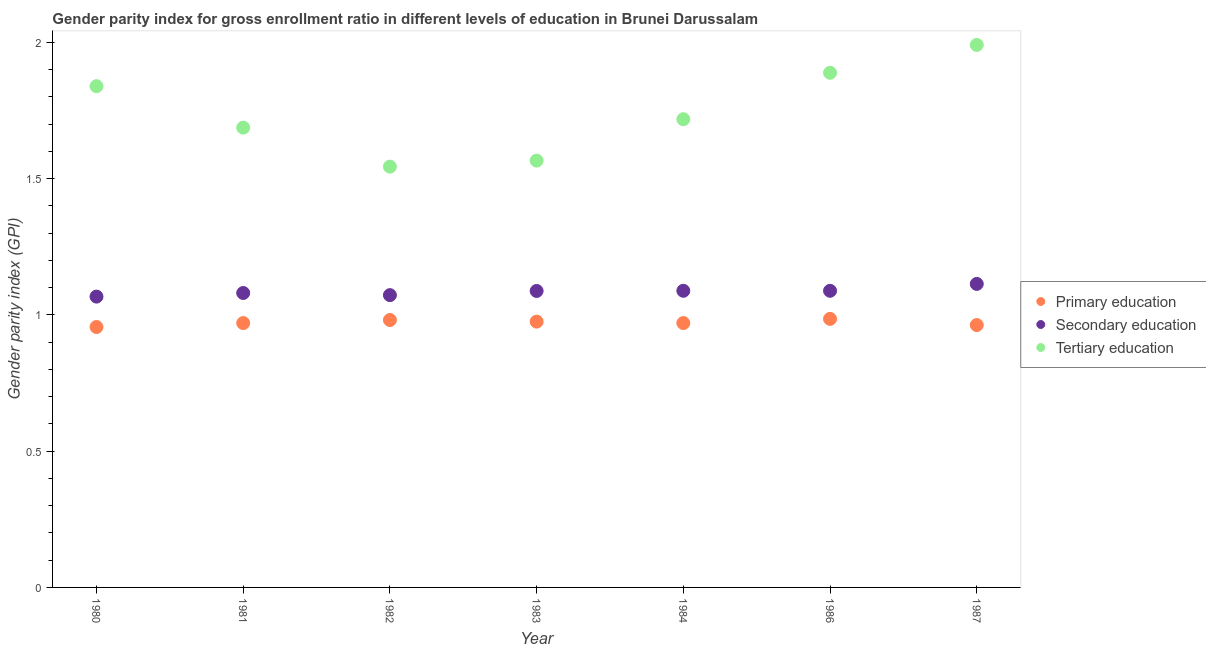What is the gender parity index in tertiary education in 1981?
Ensure brevity in your answer.  1.69. Across all years, what is the maximum gender parity index in secondary education?
Give a very brief answer. 1.11. Across all years, what is the minimum gender parity index in tertiary education?
Keep it short and to the point. 1.54. In which year was the gender parity index in tertiary education maximum?
Ensure brevity in your answer.  1987. In which year was the gender parity index in primary education minimum?
Ensure brevity in your answer.  1980. What is the total gender parity index in primary education in the graph?
Provide a short and direct response. 6.8. What is the difference between the gender parity index in primary education in 1984 and that in 1986?
Make the answer very short. -0.02. What is the difference between the gender parity index in tertiary education in 1981 and the gender parity index in secondary education in 1987?
Make the answer very short. 0.57. What is the average gender parity index in secondary education per year?
Ensure brevity in your answer.  1.09. In the year 1981, what is the difference between the gender parity index in primary education and gender parity index in tertiary education?
Make the answer very short. -0.72. What is the ratio of the gender parity index in primary education in 1986 to that in 1987?
Your answer should be compact. 1.02. Is the gender parity index in primary education in 1980 less than that in 1983?
Offer a very short reply. Yes. Is the difference between the gender parity index in secondary education in 1983 and 1986 greater than the difference between the gender parity index in primary education in 1983 and 1986?
Offer a very short reply. Yes. What is the difference between the highest and the second highest gender parity index in tertiary education?
Provide a short and direct response. 0.1. What is the difference between the highest and the lowest gender parity index in secondary education?
Offer a terse response. 0.05. Does the gender parity index in tertiary education monotonically increase over the years?
Offer a very short reply. No. Is the gender parity index in secondary education strictly greater than the gender parity index in primary education over the years?
Provide a short and direct response. Yes. Are the values on the major ticks of Y-axis written in scientific E-notation?
Your response must be concise. No. What is the title of the graph?
Your response must be concise. Gender parity index for gross enrollment ratio in different levels of education in Brunei Darussalam. What is the label or title of the Y-axis?
Provide a short and direct response. Gender parity index (GPI). What is the Gender parity index (GPI) in Primary education in 1980?
Ensure brevity in your answer.  0.96. What is the Gender parity index (GPI) of Secondary education in 1980?
Your response must be concise. 1.07. What is the Gender parity index (GPI) of Tertiary education in 1980?
Ensure brevity in your answer.  1.84. What is the Gender parity index (GPI) of Primary education in 1981?
Offer a very short reply. 0.97. What is the Gender parity index (GPI) of Secondary education in 1981?
Your answer should be very brief. 1.08. What is the Gender parity index (GPI) of Tertiary education in 1981?
Ensure brevity in your answer.  1.69. What is the Gender parity index (GPI) in Primary education in 1982?
Offer a terse response. 0.98. What is the Gender parity index (GPI) in Secondary education in 1982?
Give a very brief answer. 1.07. What is the Gender parity index (GPI) in Tertiary education in 1982?
Make the answer very short. 1.54. What is the Gender parity index (GPI) in Primary education in 1983?
Provide a short and direct response. 0.98. What is the Gender parity index (GPI) in Secondary education in 1983?
Provide a short and direct response. 1.09. What is the Gender parity index (GPI) of Tertiary education in 1983?
Offer a terse response. 1.57. What is the Gender parity index (GPI) of Primary education in 1984?
Provide a short and direct response. 0.97. What is the Gender parity index (GPI) in Secondary education in 1984?
Offer a terse response. 1.09. What is the Gender parity index (GPI) in Tertiary education in 1984?
Your response must be concise. 1.72. What is the Gender parity index (GPI) in Primary education in 1986?
Offer a terse response. 0.99. What is the Gender parity index (GPI) of Secondary education in 1986?
Keep it short and to the point. 1.09. What is the Gender parity index (GPI) of Tertiary education in 1986?
Ensure brevity in your answer.  1.89. What is the Gender parity index (GPI) of Primary education in 1987?
Make the answer very short. 0.96. What is the Gender parity index (GPI) in Secondary education in 1987?
Your answer should be compact. 1.11. What is the Gender parity index (GPI) of Tertiary education in 1987?
Your response must be concise. 1.99. Across all years, what is the maximum Gender parity index (GPI) in Primary education?
Offer a terse response. 0.99. Across all years, what is the maximum Gender parity index (GPI) of Secondary education?
Your response must be concise. 1.11. Across all years, what is the maximum Gender parity index (GPI) of Tertiary education?
Your answer should be compact. 1.99. Across all years, what is the minimum Gender parity index (GPI) in Primary education?
Make the answer very short. 0.96. Across all years, what is the minimum Gender parity index (GPI) in Secondary education?
Your answer should be very brief. 1.07. Across all years, what is the minimum Gender parity index (GPI) in Tertiary education?
Make the answer very short. 1.54. What is the total Gender parity index (GPI) in Primary education in the graph?
Your answer should be very brief. 6.8. What is the total Gender parity index (GPI) in Secondary education in the graph?
Your answer should be compact. 7.6. What is the total Gender parity index (GPI) of Tertiary education in the graph?
Make the answer very short. 12.23. What is the difference between the Gender parity index (GPI) of Primary education in 1980 and that in 1981?
Offer a terse response. -0.01. What is the difference between the Gender parity index (GPI) of Secondary education in 1980 and that in 1981?
Make the answer very short. -0.01. What is the difference between the Gender parity index (GPI) of Tertiary education in 1980 and that in 1981?
Provide a short and direct response. 0.15. What is the difference between the Gender parity index (GPI) in Primary education in 1980 and that in 1982?
Provide a short and direct response. -0.03. What is the difference between the Gender parity index (GPI) in Secondary education in 1980 and that in 1982?
Your answer should be compact. -0.01. What is the difference between the Gender parity index (GPI) of Tertiary education in 1980 and that in 1982?
Offer a terse response. 0.3. What is the difference between the Gender parity index (GPI) in Primary education in 1980 and that in 1983?
Provide a succinct answer. -0.02. What is the difference between the Gender parity index (GPI) in Secondary education in 1980 and that in 1983?
Your answer should be compact. -0.02. What is the difference between the Gender parity index (GPI) in Tertiary education in 1980 and that in 1983?
Provide a succinct answer. 0.27. What is the difference between the Gender parity index (GPI) of Primary education in 1980 and that in 1984?
Provide a short and direct response. -0.01. What is the difference between the Gender parity index (GPI) of Secondary education in 1980 and that in 1984?
Your answer should be compact. -0.02. What is the difference between the Gender parity index (GPI) of Tertiary education in 1980 and that in 1984?
Your answer should be very brief. 0.12. What is the difference between the Gender parity index (GPI) in Primary education in 1980 and that in 1986?
Give a very brief answer. -0.03. What is the difference between the Gender parity index (GPI) of Secondary education in 1980 and that in 1986?
Your answer should be very brief. -0.02. What is the difference between the Gender parity index (GPI) in Tertiary education in 1980 and that in 1986?
Keep it short and to the point. -0.05. What is the difference between the Gender parity index (GPI) in Primary education in 1980 and that in 1987?
Provide a succinct answer. -0.01. What is the difference between the Gender parity index (GPI) in Secondary education in 1980 and that in 1987?
Make the answer very short. -0.05. What is the difference between the Gender parity index (GPI) of Tertiary education in 1980 and that in 1987?
Keep it short and to the point. -0.15. What is the difference between the Gender parity index (GPI) in Primary education in 1981 and that in 1982?
Give a very brief answer. -0.01. What is the difference between the Gender parity index (GPI) of Secondary education in 1981 and that in 1982?
Your response must be concise. 0.01. What is the difference between the Gender parity index (GPI) in Tertiary education in 1981 and that in 1982?
Ensure brevity in your answer.  0.14. What is the difference between the Gender parity index (GPI) in Primary education in 1981 and that in 1983?
Provide a short and direct response. -0.01. What is the difference between the Gender parity index (GPI) in Secondary education in 1981 and that in 1983?
Your answer should be very brief. -0.01. What is the difference between the Gender parity index (GPI) of Tertiary education in 1981 and that in 1983?
Ensure brevity in your answer.  0.12. What is the difference between the Gender parity index (GPI) in Primary education in 1981 and that in 1984?
Provide a short and direct response. -0. What is the difference between the Gender parity index (GPI) in Secondary education in 1981 and that in 1984?
Your response must be concise. -0.01. What is the difference between the Gender parity index (GPI) of Tertiary education in 1981 and that in 1984?
Offer a very short reply. -0.03. What is the difference between the Gender parity index (GPI) of Primary education in 1981 and that in 1986?
Your answer should be very brief. -0.02. What is the difference between the Gender parity index (GPI) of Secondary education in 1981 and that in 1986?
Provide a succinct answer. -0.01. What is the difference between the Gender parity index (GPI) of Tertiary education in 1981 and that in 1986?
Offer a terse response. -0.2. What is the difference between the Gender parity index (GPI) of Primary education in 1981 and that in 1987?
Give a very brief answer. 0.01. What is the difference between the Gender parity index (GPI) of Secondary education in 1981 and that in 1987?
Make the answer very short. -0.03. What is the difference between the Gender parity index (GPI) in Tertiary education in 1981 and that in 1987?
Offer a terse response. -0.3. What is the difference between the Gender parity index (GPI) of Primary education in 1982 and that in 1983?
Keep it short and to the point. 0.01. What is the difference between the Gender parity index (GPI) in Secondary education in 1982 and that in 1983?
Give a very brief answer. -0.02. What is the difference between the Gender parity index (GPI) of Tertiary education in 1982 and that in 1983?
Provide a short and direct response. -0.02. What is the difference between the Gender parity index (GPI) of Primary education in 1982 and that in 1984?
Provide a succinct answer. 0.01. What is the difference between the Gender parity index (GPI) of Secondary education in 1982 and that in 1984?
Offer a terse response. -0.02. What is the difference between the Gender parity index (GPI) in Tertiary education in 1982 and that in 1984?
Your response must be concise. -0.17. What is the difference between the Gender parity index (GPI) of Primary education in 1982 and that in 1986?
Your answer should be compact. -0. What is the difference between the Gender parity index (GPI) in Secondary education in 1982 and that in 1986?
Your answer should be very brief. -0.02. What is the difference between the Gender parity index (GPI) in Tertiary education in 1982 and that in 1986?
Make the answer very short. -0.34. What is the difference between the Gender parity index (GPI) in Primary education in 1982 and that in 1987?
Provide a short and direct response. 0.02. What is the difference between the Gender parity index (GPI) of Secondary education in 1982 and that in 1987?
Make the answer very short. -0.04. What is the difference between the Gender parity index (GPI) of Tertiary education in 1982 and that in 1987?
Keep it short and to the point. -0.45. What is the difference between the Gender parity index (GPI) in Primary education in 1983 and that in 1984?
Ensure brevity in your answer.  0.01. What is the difference between the Gender parity index (GPI) in Secondary education in 1983 and that in 1984?
Your response must be concise. -0. What is the difference between the Gender parity index (GPI) in Tertiary education in 1983 and that in 1984?
Keep it short and to the point. -0.15. What is the difference between the Gender parity index (GPI) of Primary education in 1983 and that in 1986?
Give a very brief answer. -0.01. What is the difference between the Gender parity index (GPI) in Secondary education in 1983 and that in 1986?
Make the answer very short. -0. What is the difference between the Gender parity index (GPI) of Tertiary education in 1983 and that in 1986?
Your answer should be compact. -0.32. What is the difference between the Gender parity index (GPI) in Primary education in 1983 and that in 1987?
Offer a terse response. 0.01. What is the difference between the Gender parity index (GPI) of Secondary education in 1983 and that in 1987?
Your response must be concise. -0.03. What is the difference between the Gender parity index (GPI) in Tertiary education in 1983 and that in 1987?
Provide a succinct answer. -0.42. What is the difference between the Gender parity index (GPI) of Primary education in 1984 and that in 1986?
Your answer should be very brief. -0.02. What is the difference between the Gender parity index (GPI) in Secondary education in 1984 and that in 1986?
Keep it short and to the point. 0. What is the difference between the Gender parity index (GPI) in Tertiary education in 1984 and that in 1986?
Your response must be concise. -0.17. What is the difference between the Gender parity index (GPI) of Primary education in 1984 and that in 1987?
Offer a very short reply. 0.01. What is the difference between the Gender parity index (GPI) in Secondary education in 1984 and that in 1987?
Make the answer very short. -0.03. What is the difference between the Gender parity index (GPI) of Tertiary education in 1984 and that in 1987?
Provide a succinct answer. -0.27. What is the difference between the Gender parity index (GPI) of Primary education in 1986 and that in 1987?
Offer a terse response. 0.02. What is the difference between the Gender parity index (GPI) in Secondary education in 1986 and that in 1987?
Offer a terse response. -0.03. What is the difference between the Gender parity index (GPI) in Tertiary education in 1986 and that in 1987?
Give a very brief answer. -0.1. What is the difference between the Gender parity index (GPI) of Primary education in 1980 and the Gender parity index (GPI) of Secondary education in 1981?
Your answer should be compact. -0.12. What is the difference between the Gender parity index (GPI) of Primary education in 1980 and the Gender parity index (GPI) of Tertiary education in 1981?
Your answer should be very brief. -0.73. What is the difference between the Gender parity index (GPI) in Secondary education in 1980 and the Gender parity index (GPI) in Tertiary education in 1981?
Provide a succinct answer. -0.62. What is the difference between the Gender parity index (GPI) of Primary education in 1980 and the Gender parity index (GPI) of Secondary education in 1982?
Ensure brevity in your answer.  -0.12. What is the difference between the Gender parity index (GPI) in Primary education in 1980 and the Gender parity index (GPI) in Tertiary education in 1982?
Your answer should be very brief. -0.59. What is the difference between the Gender parity index (GPI) in Secondary education in 1980 and the Gender parity index (GPI) in Tertiary education in 1982?
Provide a short and direct response. -0.48. What is the difference between the Gender parity index (GPI) in Primary education in 1980 and the Gender parity index (GPI) in Secondary education in 1983?
Provide a succinct answer. -0.13. What is the difference between the Gender parity index (GPI) of Primary education in 1980 and the Gender parity index (GPI) of Tertiary education in 1983?
Provide a short and direct response. -0.61. What is the difference between the Gender parity index (GPI) of Secondary education in 1980 and the Gender parity index (GPI) of Tertiary education in 1983?
Ensure brevity in your answer.  -0.5. What is the difference between the Gender parity index (GPI) in Primary education in 1980 and the Gender parity index (GPI) in Secondary education in 1984?
Your answer should be very brief. -0.13. What is the difference between the Gender parity index (GPI) of Primary education in 1980 and the Gender parity index (GPI) of Tertiary education in 1984?
Your response must be concise. -0.76. What is the difference between the Gender parity index (GPI) of Secondary education in 1980 and the Gender parity index (GPI) of Tertiary education in 1984?
Give a very brief answer. -0.65. What is the difference between the Gender parity index (GPI) in Primary education in 1980 and the Gender parity index (GPI) in Secondary education in 1986?
Ensure brevity in your answer.  -0.13. What is the difference between the Gender parity index (GPI) of Primary education in 1980 and the Gender parity index (GPI) of Tertiary education in 1986?
Keep it short and to the point. -0.93. What is the difference between the Gender parity index (GPI) in Secondary education in 1980 and the Gender parity index (GPI) in Tertiary education in 1986?
Give a very brief answer. -0.82. What is the difference between the Gender parity index (GPI) of Primary education in 1980 and the Gender parity index (GPI) of Secondary education in 1987?
Offer a terse response. -0.16. What is the difference between the Gender parity index (GPI) in Primary education in 1980 and the Gender parity index (GPI) in Tertiary education in 1987?
Offer a terse response. -1.03. What is the difference between the Gender parity index (GPI) of Secondary education in 1980 and the Gender parity index (GPI) of Tertiary education in 1987?
Keep it short and to the point. -0.92. What is the difference between the Gender parity index (GPI) of Primary education in 1981 and the Gender parity index (GPI) of Secondary education in 1982?
Your response must be concise. -0.1. What is the difference between the Gender parity index (GPI) of Primary education in 1981 and the Gender parity index (GPI) of Tertiary education in 1982?
Offer a terse response. -0.57. What is the difference between the Gender parity index (GPI) in Secondary education in 1981 and the Gender parity index (GPI) in Tertiary education in 1982?
Make the answer very short. -0.46. What is the difference between the Gender parity index (GPI) in Primary education in 1981 and the Gender parity index (GPI) in Secondary education in 1983?
Offer a terse response. -0.12. What is the difference between the Gender parity index (GPI) in Primary education in 1981 and the Gender parity index (GPI) in Tertiary education in 1983?
Your response must be concise. -0.6. What is the difference between the Gender parity index (GPI) of Secondary education in 1981 and the Gender parity index (GPI) of Tertiary education in 1983?
Your response must be concise. -0.49. What is the difference between the Gender parity index (GPI) in Primary education in 1981 and the Gender parity index (GPI) in Secondary education in 1984?
Offer a terse response. -0.12. What is the difference between the Gender parity index (GPI) in Primary education in 1981 and the Gender parity index (GPI) in Tertiary education in 1984?
Provide a short and direct response. -0.75. What is the difference between the Gender parity index (GPI) of Secondary education in 1981 and the Gender parity index (GPI) of Tertiary education in 1984?
Offer a very short reply. -0.64. What is the difference between the Gender parity index (GPI) of Primary education in 1981 and the Gender parity index (GPI) of Secondary education in 1986?
Offer a terse response. -0.12. What is the difference between the Gender parity index (GPI) of Primary education in 1981 and the Gender parity index (GPI) of Tertiary education in 1986?
Make the answer very short. -0.92. What is the difference between the Gender parity index (GPI) in Secondary education in 1981 and the Gender parity index (GPI) in Tertiary education in 1986?
Give a very brief answer. -0.81. What is the difference between the Gender parity index (GPI) in Primary education in 1981 and the Gender parity index (GPI) in Secondary education in 1987?
Your answer should be very brief. -0.14. What is the difference between the Gender parity index (GPI) of Primary education in 1981 and the Gender parity index (GPI) of Tertiary education in 1987?
Provide a succinct answer. -1.02. What is the difference between the Gender parity index (GPI) of Secondary education in 1981 and the Gender parity index (GPI) of Tertiary education in 1987?
Provide a succinct answer. -0.91. What is the difference between the Gender parity index (GPI) of Primary education in 1982 and the Gender parity index (GPI) of Secondary education in 1983?
Your answer should be compact. -0.11. What is the difference between the Gender parity index (GPI) of Primary education in 1982 and the Gender parity index (GPI) of Tertiary education in 1983?
Your answer should be very brief. -0.58. What is the difference between the Gender parity index (GPI) in Secondary education in 1982 and the Gender parity index (GPI) in Tertiary education in 1983?
Provide a succinct answer. -0.49. What is the difference between the Gender parity index (GPI) of Primary education in 1982 and the Gender parity index (GPI) of Secondary education in 1984?
Provide a short and direct response. -0.11. What is the difference between the Gender parity index (GPI) in Primary education in 1982 and the Gender parity index (GPI) in Tertiary education in 1984?
Ensure brevity in your answer.  -0.74. What is the difference between the Gender parity index (GPI) of Secondary education in 1982 and the Gender parity index (GPI) of Tertiary education in 1984?
Your answer should be very brief. -0.65. What is the difference between the Gender parity index (GPI) of Primary education in 1982 and the Gender parity index (GPI) of Secondary education in 1986?
Provide a succinct answer. -0.11. What is the difference between the Gender parity index (GPI) in Primary education in 1982 and the Gender parity index (GPI) in Tertiary education in 1986?
Provide a short and direct response. -0.91. What is the difference between the Gender parity index (GPI) in Secondary education in 1982 and the Gender parity index (GPI) in Tertiary education in 1986?
Your response must be concise. -0.82. What is the difference between the Gender parity index (GPI) of Primary education in 1982 and the Gender parity index (GPI) of Secondary education in 1987?
Provide a short and direct response. -0.13. What is the difference between the Gender parity index (GPI) of Primary education in 1982 and the Gender parity index (GPI) of Tertiary education in 1987?
Keep it short and to the point. -1.01. What is the difference between the Gender parity index (GPI) of Secondary education in 1982 and the Gender parity index (GPI) of Tertiary education in 1987?
Your response must be concise. -0.92. What is the difference between the Gender parity index (GPI) of Primary education in 1983 and the Gender parity index (GPI) of Secondary education in 1984?
Make the answer very short. -0.11. What is the difference between the Gender parity index (GPI) of Primary education in 1983 and the Gender parity index (GPI) of Tertiary education in 1984?
Make the answer very short. -0.74. What is the difference between the Gender parity index (GPI) in Secondary education in 1983 and the Gender parity index (GPI) in Tertiary education in 1984?
Keep it short and to the point. -0.63. What is the difference between the Gender parity index (GPI) of Primary education in 1983 and the Gender parity index (GPI) of Secondary education in 1986?
Your answer should be compact. -0.11. What is the difference between the Gender parity index (GPI) of Primary education in 1983 and the Gender parity index (GPI) of Tertiary education in 1986?
Provide a succinct answer. -0.91. What is the difference between the Gender parity index (GPI) of Secondary education in 1983 and the Gender parity index (GPI) of Tertiary education in 1986?
Keep it short and to the point. -0.8. What is the difference between the Gender parity index (GPI) in Primary education in 1983 and the Gender parity index (GPI) in Secondary education in 1987?
Make the answer very short. -0.14. What is the difference between the Gender parity index (GPI) of Primary education in 1983 and the Gender parity index (GPI) of Tertiary education in 1987?
Offer a very short reply. -1.02. What is the difference between the Gender parity index (GPI) of Secondary education in 1983 and the Gender parity index (GPI) of Tertiary education in 1987?
Keep it short and to the point. -0.9. What is the difference between the Gender parity index (GPI) in Primary education in 1984 and the Gender parity index (GPI) in Secondary education in 1986?
Provide a succinct answer. -0.12. What is the difference between the Gender parity index (GPI) in Primary education in 1984 and the Gender parity index (GPI) in Tertiary education in 1986?
Keep it short and to the point. -0.92. What is the difference between the Gender parity index (GPI) of Secondary education in 1984 and the Gender parity index (GPI) of Tertiary education in 1986?
Offer a very short reply. -0.8. What is the difference between the Gender parity index (GPI) of Primary education in 1984 and the Gender parity index (GPI) of Secondary education in 1987?
Offer a very short reply. -0.14. What is the difference between the Gender parity index (GPI) of Primary education in 1984 and the Gender parity index (GPI) of Tertiary education in 1987?
Keep it short and to the point. -1.02. What is the difference between the Gender parity index (GPI) in Secondary education in 1984 and the Gender parity index (GPI) in Tertiary education in 1987?
Ensure brevity in your answer.  -0.9. What is the difference between the Gender parity index (GPI) of Primary education in 1986 and the Gender parity index (GPI) of Secondary education in 1987?
Offer a very short reply. -0.13. What is the difference between the Gender parity index (GPI) of Primary education in 1986 and the Gender parity index (GPI) of Tertiary education in 1987?
Your answer should be compact. -1.01. What is the difference between the Gender parity index (GPI) in Secondary education in 1986 and the Gender parity index (GPI) in Tertiary education in 1987?
Offer a very short reply. -0.9. What is the average Gender parity index (GPI) in Primary education per year?
Your response must be concise. 0.97. What is the average Gender parity index (GPI) of Secondary education per year?
Offer a terse response. 1.09. What is the average Gender parity index (GPI) of Tertiary education per year?
Ensure brevity in your answer.  1.75. In the year 1980, what is the difference between the Gender parity index (GPI) of Primary education and Gender parity index (GPI) of Secondary education?
Offer a very short reply. -0.11. In the year 1980, what is the difference between the Gender parity index (GPI) of Primary education and Gender parity index (GPI) of Tertiary education?
Your answer should be very brief. -0.88. In the year 1980, what is the difference between the Gender parity index (GPI) of Secondary education and Gender parity index (GPI) of Tertiary education?
Your answer should be very brief. -0.77. In the year 1981, what is the difference between the Gender parity index (GPI) of Primary education and Gender parity index (GPI) of Secondary education?
Make the answer very short. -0.11. In the year 1981, what is the difference between the Gender parity index (GPI) of Primary education and Gender parity index (GPI) of Tertiary education?
Your response must be concise. -0.72. In the year 1981, what is the difference between the Gender parity index (GPI) in Secondary education and Gender parity index (GPI) in Tertiary education?
Make the answer very short. -0.61. In the year 1982, what is the difference between the Gender parity index (GPI) in Primary education and Gender parity index (GPI) in Secondary education?
Provide a short and direct response. -0.09. In the year 1982, what is the difference between the Gender parity index (GPI) of Primary education and Gender parity index (GPI) of Tertiary education?
Offer a terse response. -0.56. In the year 1982, what is the difference between the Gender parity index (GPI) of Secondary education and Gender parity index (GPI) of Tertiary education?
Your response must be concise. -0.47. In the year 1983, what is the difference between the Gender parity index (GPI) of Primary education and Gender parity index (GPI) of Secondary education?
Make the answer very short. -0.11. In the year 1983, what is the difference between the Gender parity index (GPI) of Primary education and Gender parity index (GPI) of Tertiary education?
Your answer should be compact. -0.59. In the year 1983, what is the difference between the Gender parity index (GPI) of Secondary education and Gender parity index (GPI) of Tertiary education?
Keep it short and to the point. -0.48. In the year 1984, what is the difference between the Gender parity index (GPI) of Primary education and Gender parity index (GPI) of Secondary education?
Provide a short and direct response. -0.12. In the year 1984, what is the difference between the Gender parity index (GPI) in Primary education and Gender parity index (GPI) in Tertiary education?
Provide a succinct answer. -0.75. In the year 1984, what is the difference between the Gender parity index (GPI) in Secondary education and Gender parity index (GPI) in Tertiary education?
Offer a very short reply. -0.63. In the year 1986, what is the difference between the Gender parity index (GPI) of Primary education and Gender parity index (GPI) of Secondary education?
Offer a terse response. -0.1. In the year 1986, what is the difference between the Gender parity index (GPI) in Primary education and Gender parity index (GPI) in Tertiary education?
Offer a terse response. -0.9. In the year 1986, what is the difference between the Gender parity index (GPI) in Secondary education and Gender parity index (GPI) in Tertiary education?
Provide a succinct answer. -0.8. In the year 1987, what is the difference between the Gender parity index (GPI) in Primary education and Gender parity index (GPI) in Secondary education?
Offer a terse response. -0.15. In the year 1987, what is the difference between the Gender parity index (GPI) of Primary education and Gender parity index (GPI) of Tertiary education?
Offer a terse response. -1.03. In the year 1987, what is the difference between the Gender parity index (GPI) of Secondary education and Gender parity index (GPI) of Tertiary education?
Offer a very short reply. -0.88. What is the ratio of the Gender parity index (GPI) in Primary education in 1980 to that in 1981?
Your response must be concise. 0.99. What is the ratio of the Gender parity index (GPI) of Secondary education in 1980 to that in 1981?
Give a very brief answer. 0.99. What is the ratio of the Gender parity index (GPI) in Tertiary education in 1980 to that in 1981?
Keep it short and to the point. 1.09. What is the ratio of the Gender parity index (GPI) of Primary education in 1980 to that in 1982?
Offer a terse response. 0.97. What is the ratio of the Gender parity index (GPI) of Secondary education in 1980 to that in 1982?
Ensure brevity in your answer.  0.99. What is the ratio of the Gender parity index (GPI) in Tertiary education in 1980 to that in 1982?
Provide a succinct answer. 1.19. What is the ratio of the Gender parity index (GPI) of Primary education in 1980 to that in 1983?
Your answer should be compact. 0.98. What is the ratio of the Gender parity index (GPI) in Secondary education in 1980 to that in 1983?
Your response must be concise. 0.98. What is the ratio of the Gender parity index (GPI) in Tertiary education in 1980 to that in 1983?
Provide a succinct answer. 1.17. What is the ratio of the Gender parity index (GPI) of Secondary education in 1980 to that in 1984?
Offer a very short reply. 0.98. What is the ratio of the Gender parity index (GPI) in Tertiary education in 1980 to that in 1984?
Offer a very short reply. 1.07. What is the ratio of the Gender parity index (GPI) in Primary education in 1980 to that in 1986?
Offer a very short reply. 0.97. What is the ratio of the Gender parity index (GPI) of Secondary education in 1980 to that in 1986?
Give a very brief answer. 0.98. What is the ratio of the Gender parity index (GPI) in Tertiary education in 1980 to that in 1986?
Your answer should be compact. 0.97. What is the ratio of the Gender parity index (GPI) of Primary education in 1980 to that in 1987?
Make the answer very short. 0.99. What is the ratio of the Gender parity index (GPI) in Secondary education in 1980 to that in 1987?
Provide a succinct answer. 0.96. What is the ratio of the Gender parity index (GPI) of Tertiary education in 1980 to that in 1987?
Offer a very short reply. 0.92. What is the ratio of the Gender parity index (GPI) in Primary education in 1981 to that in 1982?
Provide a short and direct response. 0.99. What is the ratio of the Gender parity index (GPI) in Secondary education in 1981 to that in 1982?
Offer a terse response. 1.01. What is the ratio of the Gender parity index (GPI) in Tertiary education in 1981 to that in 1982?
Your answer should be compact. 1.09. What is the ratio of the Gender parity index (GPI) of Primary education in 1981 to that in 1983?
Your response must be concise. 0.99. What is the ratio of the Gender parity index (GPI) of Tertiary education in 1981 to that in 1983?
Keep it short and to the point. 1.08. What is the ratio of the Gender parity index (GPI) of Primary education in 1981 to that in 1986?
Offer a terse response. 0.98. What is the ratio of the Gender parity index (GPI) in Secondary education in 1981 to that in 1986?
Offer a very short reply. 0.99. What is the ratio of the Gender parity index (GPI) in Tertiary education in 1981 to that in 1986?
Your response must be concise. 0.89. What is the ratio of the Gender parity index (GPI) of Primary education in 1981 to that in 1987?
Offer a very short reply. 1.01. What is the ratio of the Gender parity index (GPI) of Secondary education in 1981 to that in 1987?
Your answer should be very brief. 0.97. What is the ratio of the Gender parity index (GPI) of Tertiary education in 1981 to that in 1987?
Keep it short and to the point. 0.85. What is the ratio of the Gender parity index (GPI) of Primary education in 1982 to that in 1983?
Give a very brief answer. 1.01. What is the ratio of the Gender parity index (GPI) of Secondary education in 1982 to that in 1983?
Provide a short and direct response. 0.99. What is the ratio of the Gender parity index (GPI) in Tertiary education in 1982 to that in 1983?
Give a very brief answer. 0.99. What is the ratio of the Gender parity index (GPI) in Primary education in 1982 to that in 1984?
Make the answer very short. 1.01. What is the ratio of the Gender parity index (GPI) in Tertiary education in 1982 to that in 1984?
Your answer should be compact. 0.9. What is the ratio of the Gender parity index (GPI) of Primary education in 1982 to that in 1986?
Offer a very short reply. 1. What is the ratio of the Gender parity index (GPI) of Secondary education in 1982 to that in 1986?
Give a very brief answer. 0.99. What is the ratio of the Gender parity index (GPI) of Tertiary education in 1982 to that in 1986?
Give a very brief answer. 0.82. What is the ratio of the Gender parity index (GPI) in Primary education in 1982 to that in 1987?
Ensure brevity in your answer.  1.02. What is the ratio of the Gender parity index (GPI) of Secondary education in 1982 to that in 1987?
Keep it short and to the point. 0.96. What is the ratio of the Gender parity index (GPI) of Tertiary education in 1982 to that in 1987?
Your answer should be compact. 0.78. What is the ratio of the Gender parity index (GPI) of Tertiary education in 1983 to that in 1984?
Keep it short and to the point. 0.91. What is the ratio of the Gender parity index (GPI) of Primary education in 1983 to that in 1986?
Your answer should be compact. 0.99. What is the ratio of the Gender parity index (GPI) in Tertiary education in 1983 to that in 1986?
Ensure brevity in your answer.  0.83. What is the ratio of the Gender parity index (GPI) of Primary education in 1983 to that in 1987?
Offer a very short reply. 1.01. What is the ratio of the Gender parity index (GPI) of Secondary education in 1983 to that in 1987?
Ensure brevity in your answer.  0.98. What is the ratio of the Gender parity index (GPI) in Tertiary education in 1983 to that in 1987?
Your response must be concise. 0.79. What is the ratio of the Gender parity index (GPI) in Primary education in 1984 to that in 1986?
Provide a succinct answer. 0.98. What is the ratio of the Gender parity index (GPI) in Tertiary education in 1984 to that in 1986?
Provide a short and direct response. 0.91. What is the ratio of the Gender parity index (GPI) in Primary education in 1984 to that in 1987?
Your response must be concise. 1.01. What is the ratio of the Gender parity index (GPI) in Secondary education in 1984 to that in 1987?
Provide a short and direct response. 0.98. What is the ratio of the Gender parity index (GPI) of Tertiary education in 1984 to that in 1987?
Offer a terse response. 0.86. What is the ratio of the Gender parity index (GPI) in Primary education in 1986 to that in 1987?
Your answer should be compact. 1.02. What is the ratio of the Gender parity index (GPI) of Secondary education in 1986 to that in 1987?
Offer a very short reply. 0.98. What is the ratio of the Gender parity index (GPI) of Tertiary education in 1986 to that in 1987?
Make the answer very short. 0.95. What is the difference between the highest and the second highest Gender parity index (GPI) in Primary education?
Ensure brevity in your answer.  0. What is the difference between the highest and the second highest Gender parity index (GPI) of Secondary education?
Give a very brief answer. 0.03. What is the difference between the highest and the second highest Gender parity index (GPI) in Tertiary education?
Ensure brevity in your answer.  0.1. What is the difference between the highest and the lowest Gender parity index (GPI) of Primary education?
Your answer should be compact. 0.03. What is the difference between the highest and the lowest Gender parity index (GPI) of Secondary education?
Offer a very short reply. 0.05. What is the difference between the highest and the lowest Gender parity index (GPI) in Tertiary education?
Offer a terse response. 0.45. 